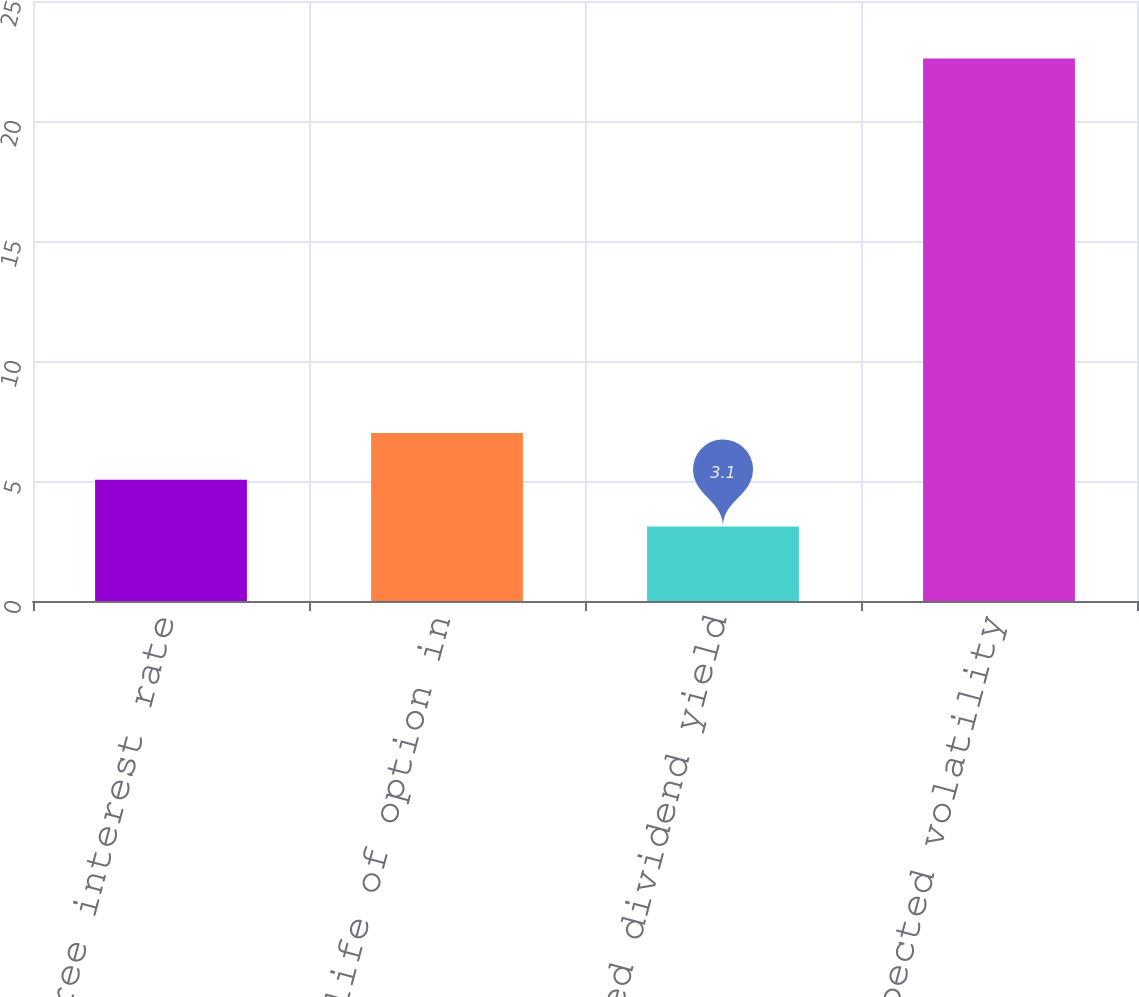<chart> <loc_0><loc_0><loc_500><loc_500><bar_chart><fcel>Risk free interest rate<fcel>Expected life of option in<fcel>Expected dividend yield<fcel>Expected volatility<nl><fcel>5.05<fcel>7<fcel>3.1<fcel>22.6<nl></chart> 